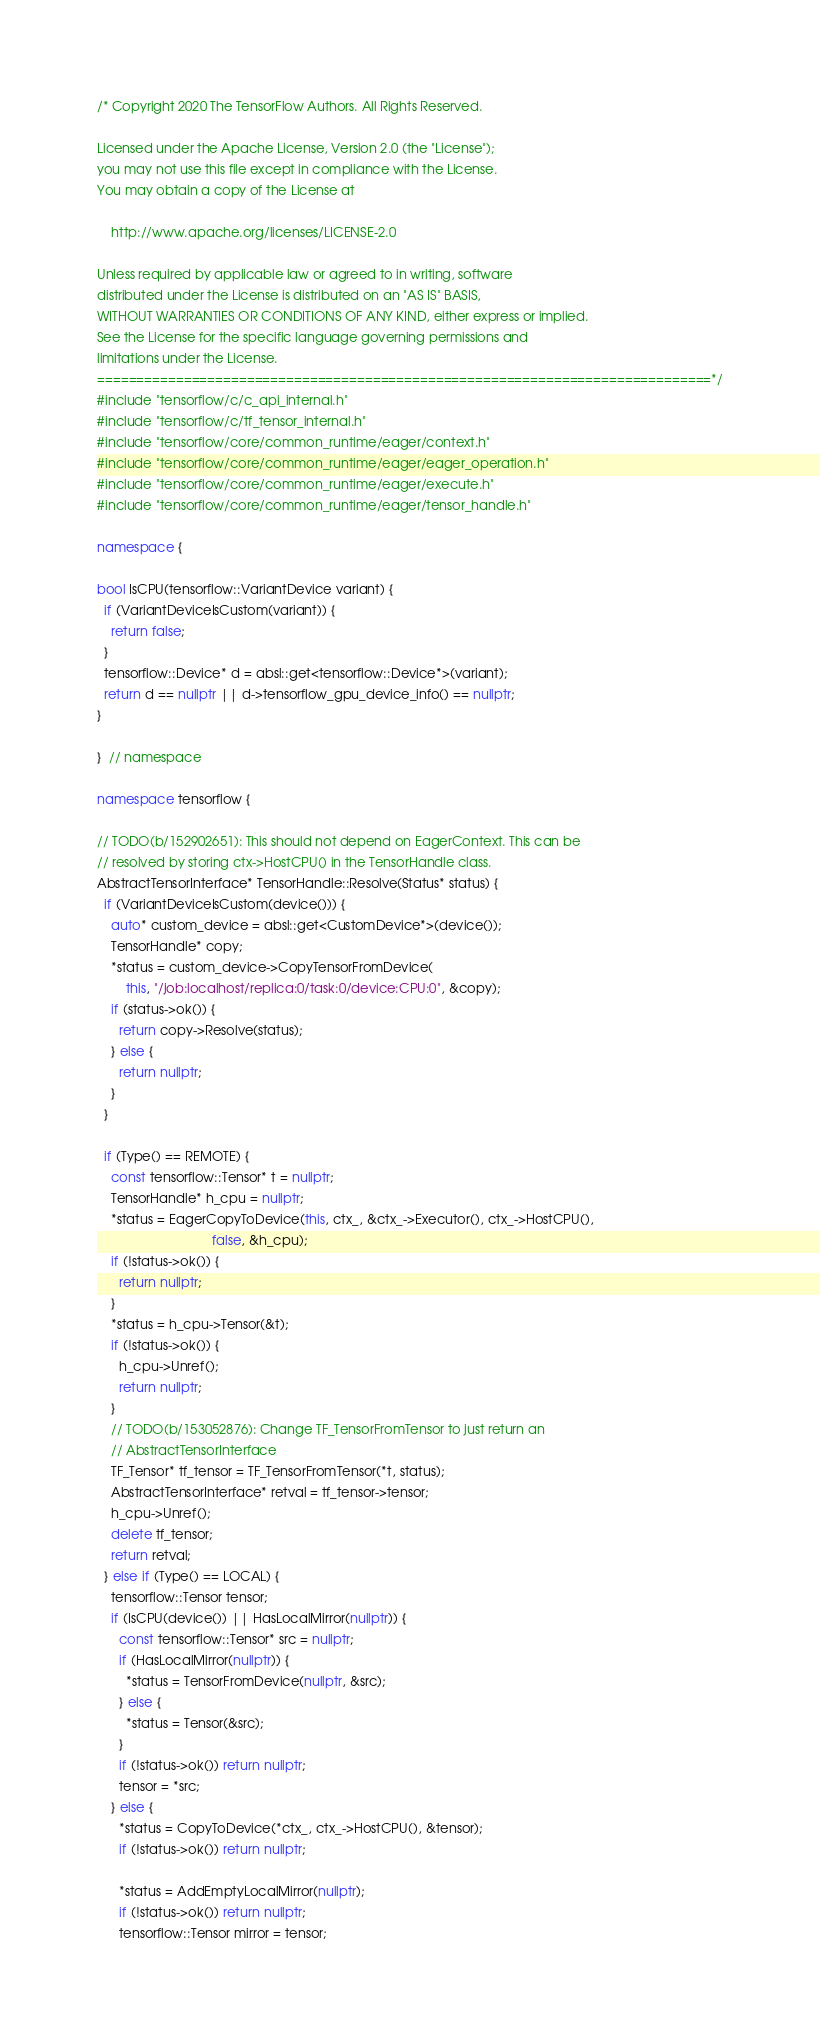<code> <loc_0><loc_0><loc_500><loc_500><_C++_>/* Copyright 2020 The TensorFlow Authors. All Rights Reserved.

Licensed under the Apache License, Version 2.0 (the "License");
you may not use this file except in compliance with the License.
You may obtain a copy of the License at

    http://www.apache.org/licenses/LICENSE-2.0

Unless required by applicable law or agreed to in writing, software
distributed under the License is distributed on an "AS IS" BASIS,
WITHOUT WARRANTIES OR CONDITIONS OF ANY KIND, either express or implied.
See the License for the specific language governing permissions and
limitations under the License.
==============================================================================*/
#include "tensorflow/c/c_api_internal.h"
#include "tensorflow/c/tf_tensor_internal.h"
#include "tensorflow/core/common_runtime/eager/context.h"
#include "tensorflow/core/common_runtime/eager/eager_operation.h"
#include "tensorflow/core/common_runtime/eager/execute.h"
#include "tensorflow/core/common_runtime/eager/tensor_handle.h"

namespace {

bool IsCPU(tensorflow::VariantDevice variant) {
  if (VariantDeviceIsCustom(variant)) {
    return false;
  }
  tensorflow::Device* d = absl::get<tensorflow::Device*>(variant);
  return d == nullptr || d->tensorflow_gpu_device_info() == nullptr;
}

}  // namespace

namespace tensorflow {

// TODO(b/152902651): This should not depend on EagerContext. This can be
// resolved by storing ctx->HostCPU() in the TensorHandle class.
AbstractTensorInterface* TensorHandle::Resolve(Status* status) {
  if (VariantDeviceIsCustom(device())) {
    auto* custom_device = absl::get<CustomDevice*>(device());
    TensorHandle* copy;
    *status = custom_device->CopyTensorFromDevice(
        this, "/job:localhost/replica:0/task:0/device:CPU:0", &copy);
    if (status->ok()) {
      return copy->Resolve(status);
    } else {
      return nullptr;
    }
  }

  if (Type() == REMOTE) {
    const tensorflow::Tensor* t = nullptr;
    TensorHandle* h_cpu = nullptr;
    *status = EagerCopyToDevice(this, ctx_, &ctx_->Executor(), ctx_->HostCPU(),
                                false, &h_cpu);
    if (!status->ok()) {
      return nullptr;
    }
    *status = h_cpu->Tensor(&t);
    if (!status->ok()) {
      h_cpu->Unref();
      return nullptr;
    }
    // TODO(b/153052876): Change TF_TensorFromTensor to just return an
    // AbstractTensorInterface
    TF_Tensor* tf_tensor = TF_TensorFromTensor(*t, status);
    AbstractTensorInterface* retval = tf_tensor->tensor;
    h_cpu->Unref();
    delete tf_tensor;
    return retval;
  } else if (Type() == LOCAL) {
    tensorflow::Tensor tensor;
    if (IsCPU(device()) || HasLocalMirror(nullptr)) {
      const tensorflow::Tensor* src = nullptr;
      if (HasLocalMirror(nullptr)) {
        *status = TensorFromDevice(nullptr, &src);
      } else {
        *status = Tensor(&src);
      }
      if (!status->ok()) return nullptr;
      tensor = *src;
    } else {
      *status = CopyToDevice(*ctx_, ctx_->HostCPU(), &tensor);
      if (!status->ok()) return nullptr;

      *status = AddEmptyLocalMirror(nullptr);
      if (!status->ok()) return nullptr;
      tensorflow::Tensor mirror = tensor;</code> 